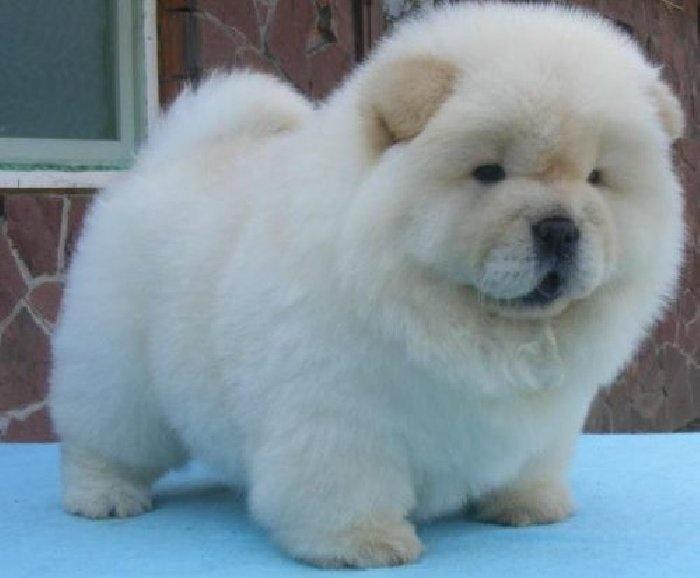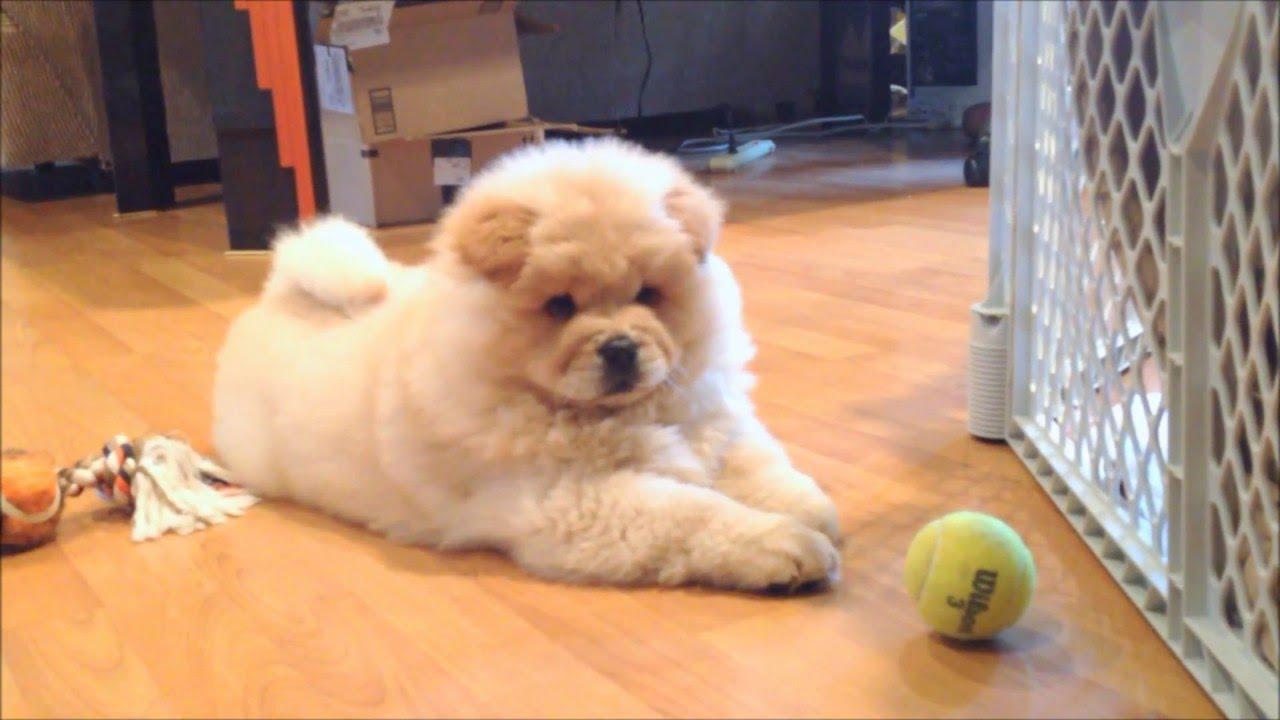The first image is the image on the left, the second image is the image on the right. Considering the images on both sides, is "The right image shows a pale cream-colored chow pup standing on all fours." valid? Answer yes or no. No. 